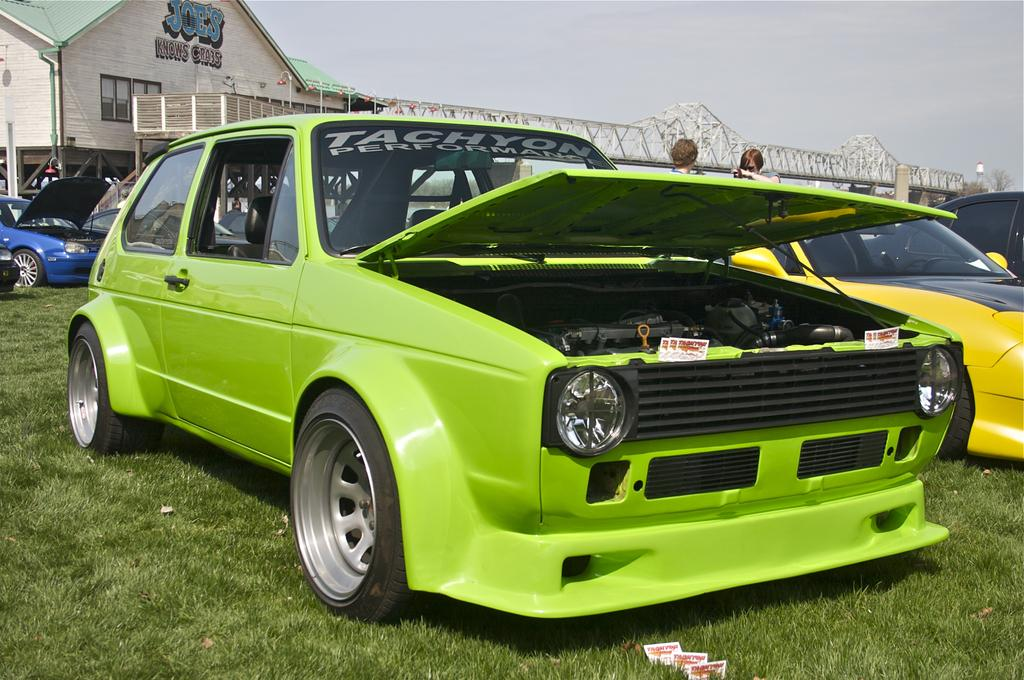Who or what can be seen in the image? There are people in the image. What else is present in the image besides people? A: There are cars in the image. Where are the cars and people located? The cars and people are on the grass. What can be seen in the background of the image? There is a building, trees, and a bridge in the background of the image. What type of toys can be seen on the bridge in the image? There are no toys present in the image, and the bridge is not mentioned as having any objects on it. 